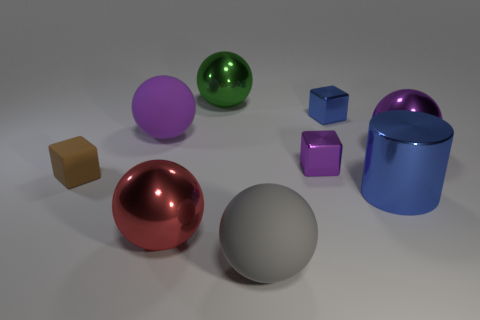Subtract all gray balls. How many balls are left? 4 Subtract all cyan balls. Subtract all brown cubes. How many balls are left? 5 Add 1 tiny gray things. How many objects exist? 10 Subtract all balls. How many objects are left? 4 Subtract all purple rubber spheres. Subtract all blue shiny blocks. How many objects are left? 7 Add 3 gray matte things. How many gray matte things are left? 4 Add 2 blue matte cylinders. How many blue matte cylinders exist? 2 Subtract 0 blue spheres. How many objects are left? 9 